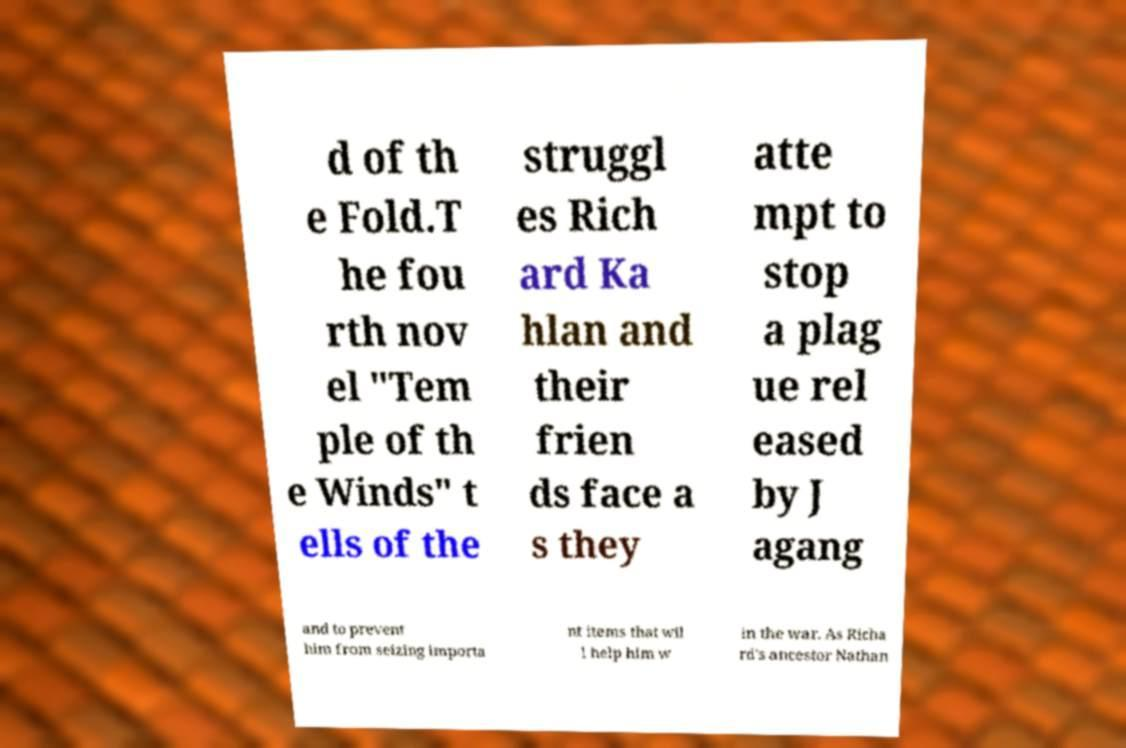What messages or text are displayed in this image? I need them in a readable, typed format. d of th e Fold.T he fou rth nov el "Tem ple of th e Winds" t ells of the struggl es Rich ard Ka hlan and their frien ds face a s they atte mpt to stop a plag ue rel eased by J agang and to prevent him from seizing importa nt items that wil l help him w in the war. As Richa rd's ancestor Nathan 